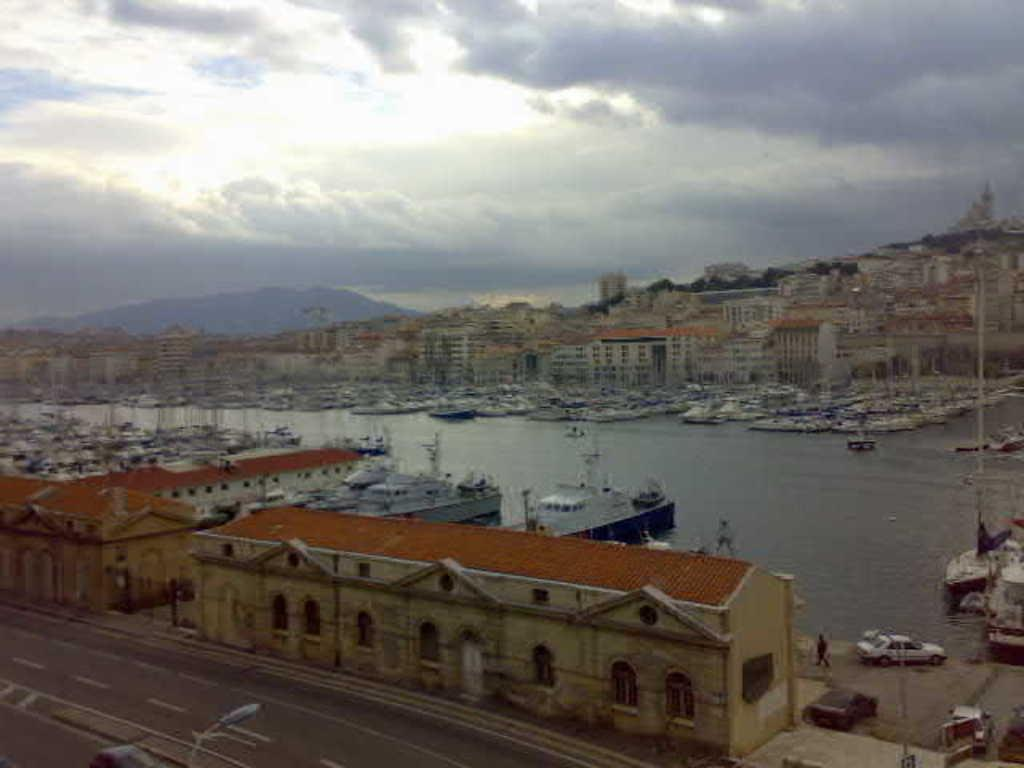What is located at the bottom of the image? There is a road at the bottom of the image. What structures are near the road? There are houses near the road. What can be seen in the middle of the image? There are ships in the water in the middle of the image. What is visible at the top of the image? The sky is visible at the top of the image. How would you describe the sky in the image? The sky appears to be cloudy. What type of account is being discussed in the image? There is no account being discussed in the image; it features a road, houses, ships, and a cloudy sky. Can you tell me how many cars are parked on the floor in the image? There is no floor or cars present in the image. 